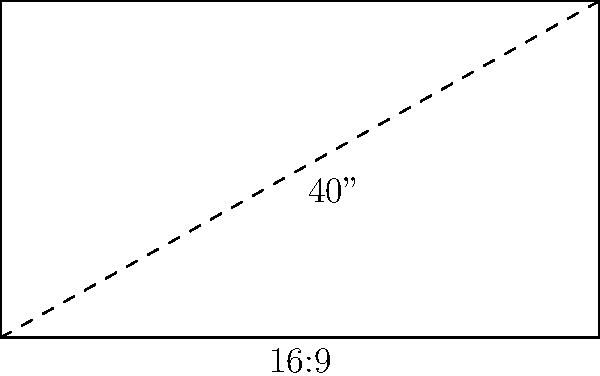As a TV show host, you're intrigued by the specifications of your new studio monitor. The screen has a diagonal measurement of 40 inches and an aspect ratio of 16:9. What is the width of this TV screen in inches? Let's approach this step-by-step:

1) In a rectangle with an aspect ratio of 16:9, let the width be $16x$ and the height be $9x$, where $x$ is some scaling factor.

2) Using the Pythagorean theorem, we can set up an equation:
   $$(16x)^2 + (9x)^2 = 40^2$$

3) Simplify:
   $$256x^2 + 81x^2 = 1600$$
   $$337x^2 = 1600$$

4) Solve for $x$:
   $$x^2 = \frac{1600}{337}$$
   $$x = \sqrt{\frac{1600}{337}} \approx 2.18$$

5) The width of the TV is $16x$:
   $$16 * 2.18 \approx 34.87$$

Therefore, the width of the TV screen is approximately 34.87 inches.
Answer: 34.87 inches 